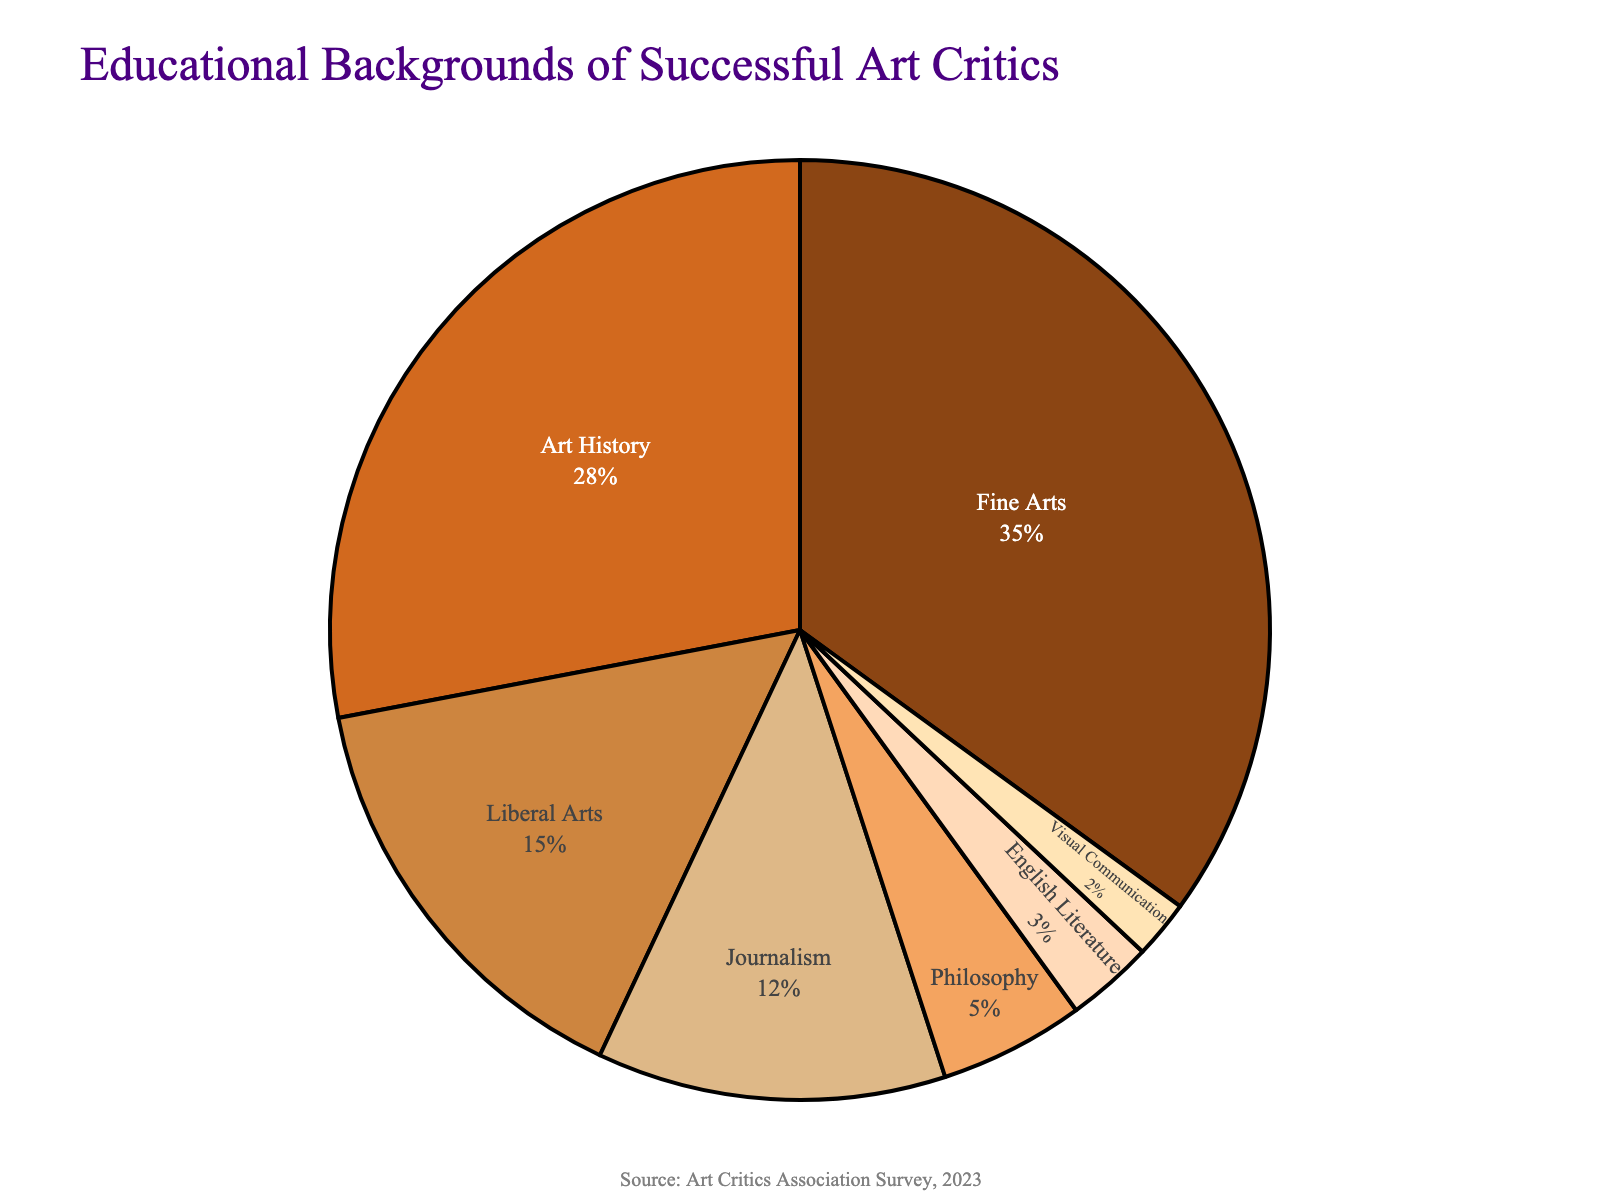What's the largest percentage represented among educational backgrounds? The pie chart shows the educational background breakdown, where Fine Arts holds the largest portion. By examining the segment sizes and the corresponding labels, Fine Arts covers 35%.
Answer: Fine Arts, 35% Which two educational backgrounds combined make up nearly half of the successful art critics? Summing the percentages of Fine Arts (35%) and Art History (28%) gives a total of 63%, which is well above half. To find close to half, adding Liberal Arts (15%) to Fine Arts (35%) equals 50%, exactly half.
Answer: Fine Arts and Liberal Arts, 50% What percentage do Journalism and Philosophy together account for? Looking at the chart, Journalism is 12% and Philosophy is 5%. Adding these two values together, 12% + 5% = 17%.
Answer: 17% Is there any educational background represented by a percentage less than 5%? The chart shows segments and labels. Philosophy has 5%, English Literature has 3%, and Visual Communication has 2%. Both English Literature and Visual Communication are less than 5%.
Answer: Yes Which segment is represented by the darkest color? The colors used range from light to dark based on their position in the pie chart. Fine Arts is represented by the darkest color, which is a dark brown.
Answer: Fine Arts Compare the percentage of critics with a background in Liberal Arts to those with an Art History background. Which is larger and by how much? The chart shows Liberal Arts at 15% and Art History at 28%. Subtracting the two gives us 28% - 15% = 13%. Art History is larger by 13%.
Answer: Art History, by 13% What's the combined percentage for the least common three educational backgrounds? The least common backgrounds displayed are English Literature (3%), Visual Communication (2%), and Philosophy (5%). Summing these percentages, 3% + 2% + 5% = 10%.
Answer: 10% What two educational backgrounds combined make up less than 10%? The chart shows that English Literature is 3% and Visual Communication is 2%. Adding these two yields 3% + 2% = 5%, which is less than 10%.
Answer: English Literature and Visual Communication, 5% What is the average percentage among Fine Arts, Liberal Arts, and Journalism? To find the average, sum the percentages: Fine Arts (35%), Liberal Arts (15%), and Journalism (12%). The total is 35% + 15% + 12% = 62%. Dividing by 3 gives 62% / 3 ≈ 20.67%.
Answer: ≈ 20.67% Which educational background has the smallest representation, and what percentage is it? The chart shows that the smallest segment is Visual Communication, represented by 2%.
Answer: Visual Communication, 2% 